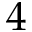<formula> <loc_0><loc_0><loc_500><loc_500>4</formula> 